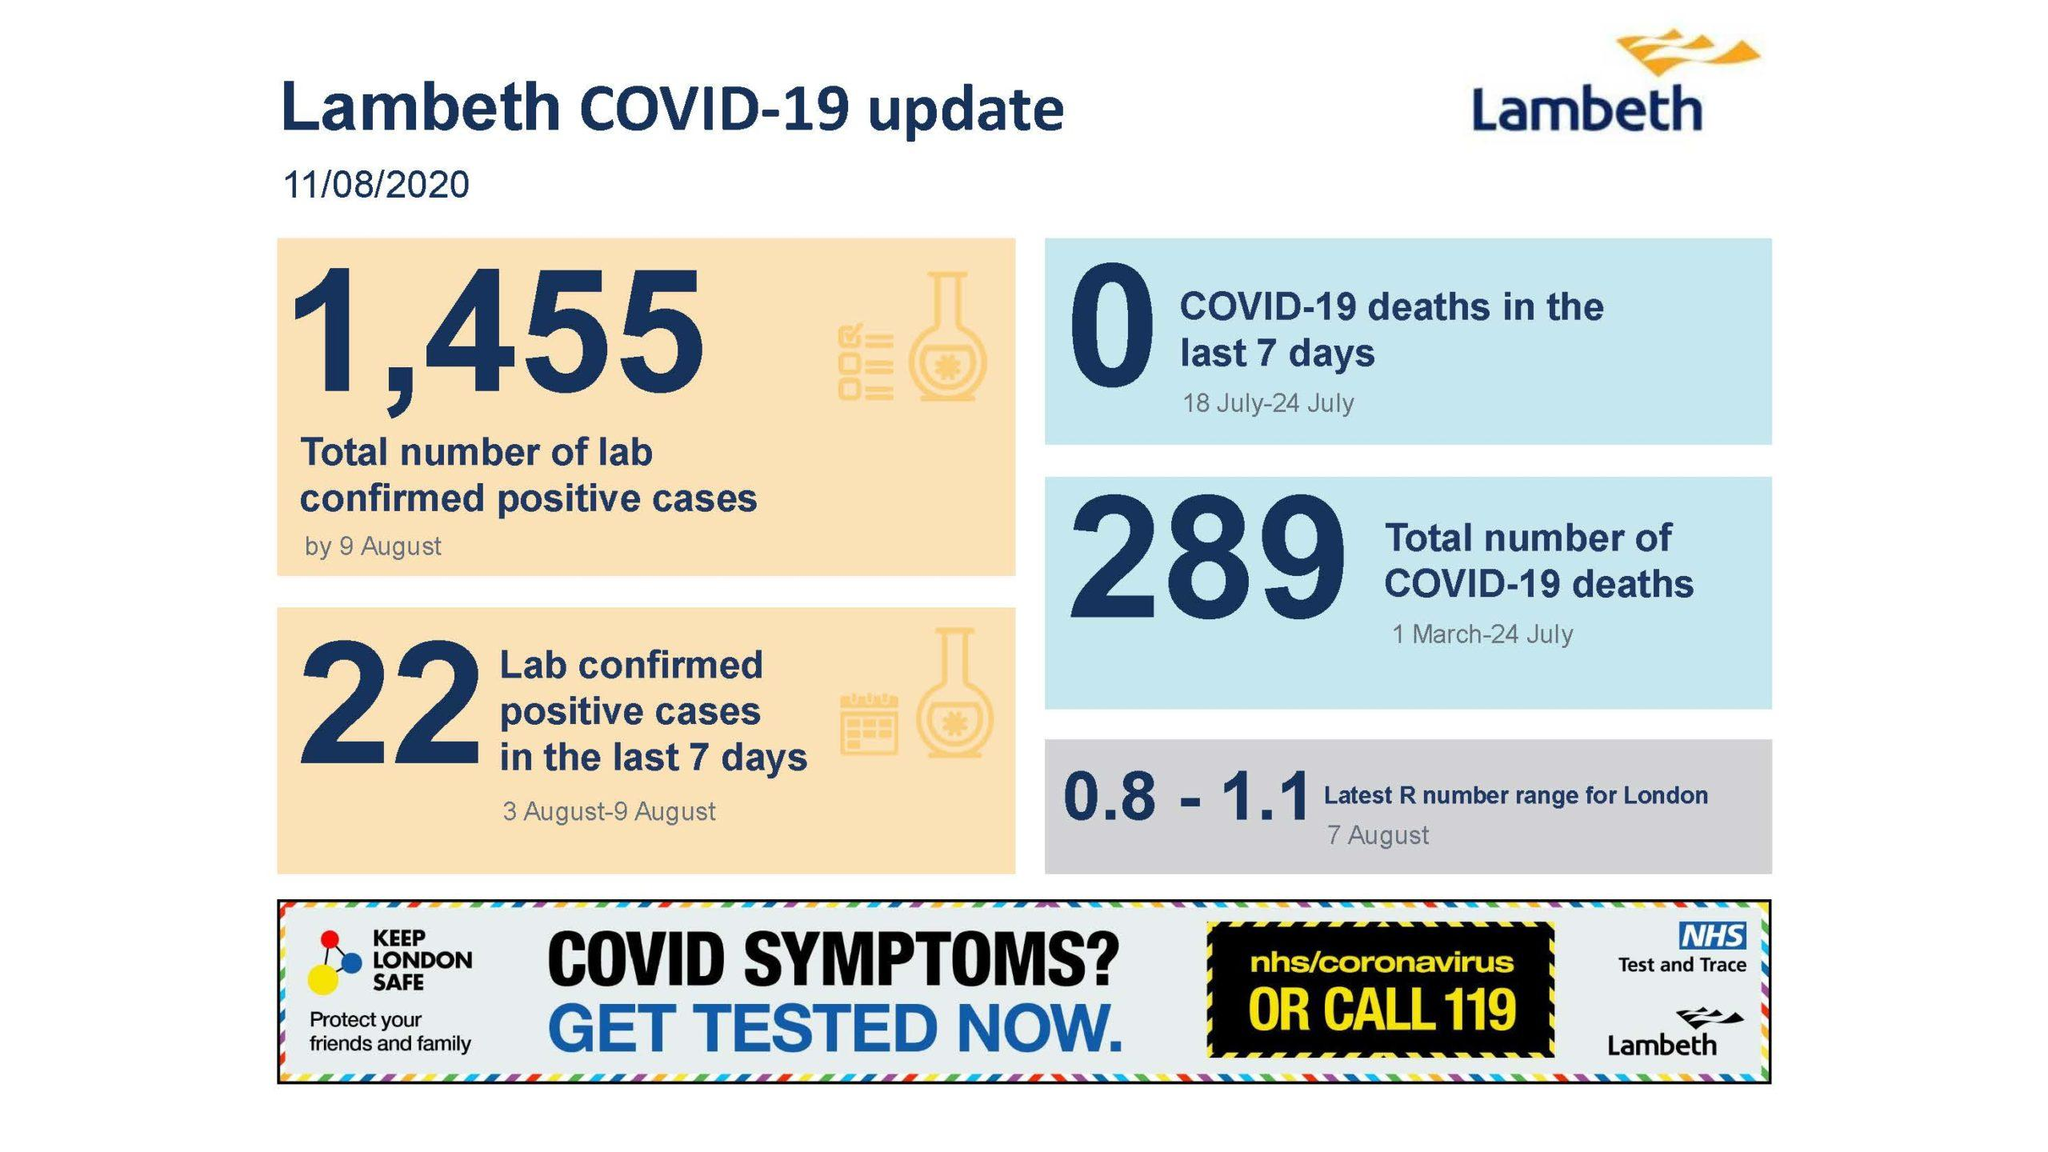Highlight a few significant elements in this photo. The number of confirmed Coronavirus patients who lost their lives the previous week is zero. There were 1,455 laboratories that confirmed cases of COVID-19 on August 9, 2020. On March 1 and July 24, a total of 289 individuals lost their lives. 22 labs have verified the presence of the coronavirus in the previous week. On which date was the latest R number range taken? It was taken on August 7th. 